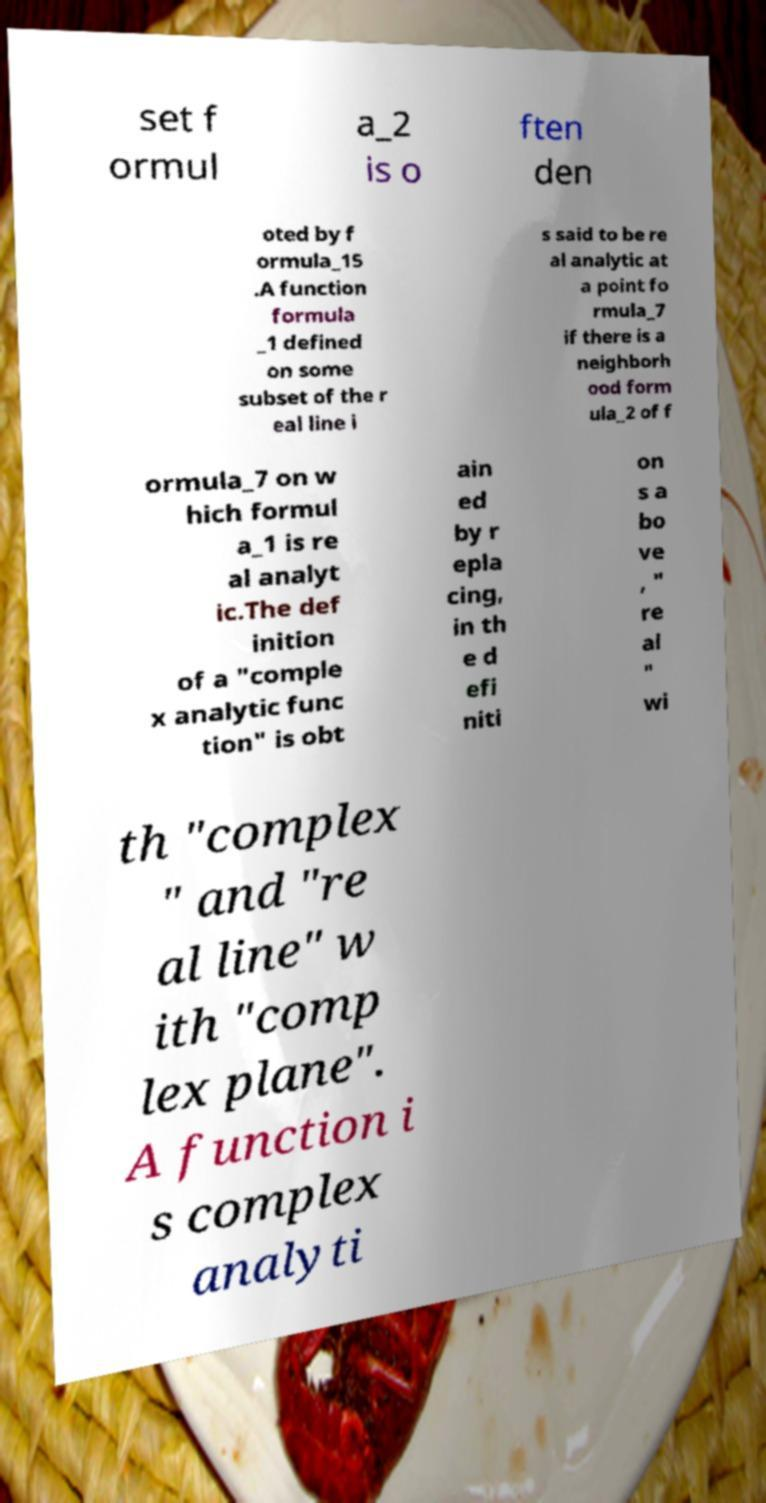Please read and relay the text visible in this image. What does it say? set f ormul a_2 is o ften den oted by f ormula_15 .A function formula _1 defined on some subset of the r eal line i s said to be re al analytic at a point fo rmula_7 if there is a neighborh ood form ula_2 of f ormula_7 on w hich formul a_1 is re al analyt ic.The def inition of a "comple x analytic func tion" is obt ain ed by r epla cing, in th e d efi niti on s a bo ve , " re al " wi th "complex " and "re al line" w ith "comp lex plane". A function i s complex analyti 